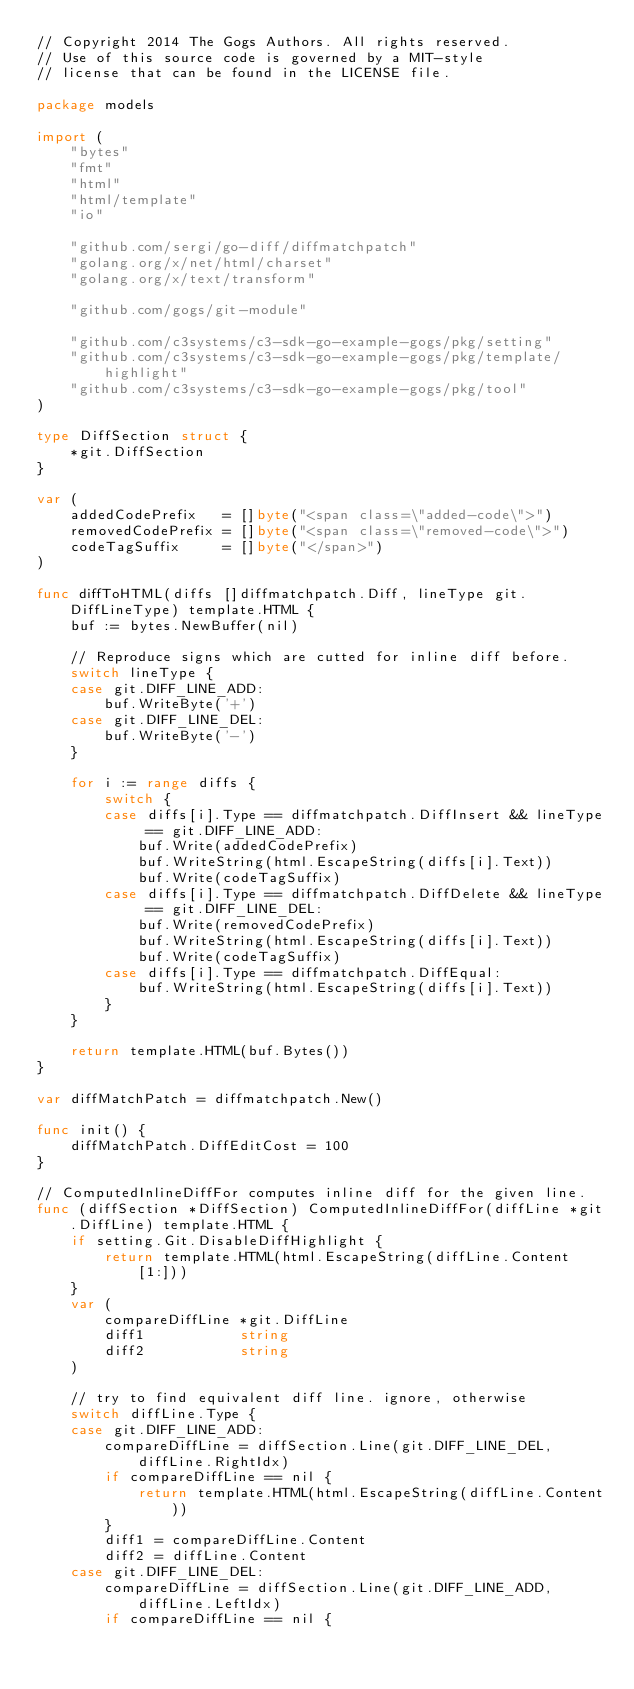<code> <loc_0><loc_0><loc_500><loc_500><_Go_>// Copyright 2014 The Gogs Authors. All rights reserved.
// Use of this source code is governed by a MIT-style
// license that can be found in the LICENSE file.

package models

import (
	"bytes"
	"fmt"
	"html"
	"html/template"
	"io"

	"github.com/sergi/go-diff/diffmatchpatch"
	"golang.org/x/net/html/charset"
	"golang.org/x/text/transform"

	"github.com/gogs/git-module"

	"github.com/c3systems/c3-sdk-go-example-gogs/pkg/setting"
	"github.com/c3systems/c3-sdk-go-example-gogs/pkg/template/highlight"
	"github.com/c3systems/c3-sdk-go-example-gogs/pkg/tool"
)

type DiffSection struct {
	*git.DiffSection
}

var (
	addedCodePrefix   = []byte("<span class=\"added-code\">")
	removedCodePrefix = []byte("<span class=\"removed-code\">")
	codeTagSuffix     = []byte("</span>")
)

func diffToHTML(diffs []diffmatchpatch.Diff, lineType git.DiffLineType) template.HTML {
	buf := bytes.NewBuffer(nil)

	// Reproduce signs which are cutted for inline diff before.
	switch lineType {
	case git.DIFF_LINE_ADD:
		buf.WriteByte('+')
	case git.DIFF_LINE_DEL:
		buf.WriteByte('-')
	}

	for i := range diffs {
		switch {
		case diffs[i].Type == diffmatchpatch.DiffInsert && lineType == git.DIFF_LINE_ADD:
			buf.Write(addedCodePrefix)
			buf.WriteString(html.EscapeString(diffs[i].Text))
			buf.Write(codeTagSuffix)
		case diffs[i].Type == diffmatchpatch.DiffDelete && lineType == git.DIFF_LINE_DEL:
			buf.Write(removedCodePrefix)
			buf.WriteString(html.EscapeString(diffs[i].Text))
			buf.Write(codeTagSuffix)
		case diffs[i].Type == diffmatchpatch.DiffEqual:
			buf.WriteString(html.EscapeString(diffs[i].Text))
		}
	}

	return template.HTML(buf.Bytes())
}

var diffMatchPatch = diffmatchpatch.New()

func init() {
	diffMatchPatch.DiffEditCost = 100
}

// ComputedInlineDiffFor computes inline diff for the given line.
func (diffSection *DiffSection) ComputedInlineDiffFor(diffLine *git.DiffLine) template.HTML {
	if setting.Git.DisableDiffHighlight {
		return template.HTML(html.EscapeString(diffLine.Content[1:]))
	}
	var (
		compareDiffLine *git.DiffLine
		diff1           string
		diff2           string
	)

	// try to find equivalent diff line. ignore, otherwise
	switch diffLine.Type {
	case git.DIFF_LINE_ADD:
		compareDiffLine = diffSection.Line(git.DIFF_LINE_DEL, diffLine.RightIdx)
		if compareDiffLine == nil {
			return template.HTML(html.EscapeString(diffLine.Content))
		}
		diff1 = compareDiffLine.Content
		diff2 = diffLine.Content
	case git.DIFF_LINE_DEL:
		compareDiffLine = diffSection.Line(git.DIFF_LINE_ADD, diffLine.LeftIdx)
		if compareDiffLine == nil {</code> 